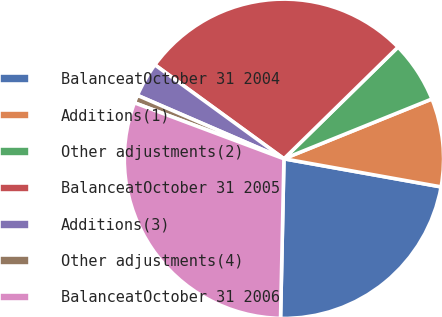Convert chart. <chart><loc_0><loc_0><loc_500><loc_500><pie_chart><fcel>BalanceatOctober 31 2004<fcel>Additions(1)<fcel>Other adjustments(2)<fcel>BalanceatOctober 31 2005<fcel>Additions(3)<fcel>Other adjustments(4)<fcel>BalanceatOctober 31 2006<nl><fcel>22.52%<fcel>8.93%<fcel>6.22%<fcel>27.65%<fcel>3.51%<fcel>0.8%<fcel>30.36%<nl></chart> 